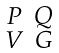Convert formula to latex. <formula><loc_0><loc_0><loc_500><loc_500>\begin{smallmatrix} P & Q \\ V & G \end{smallmatrix}</formula> 